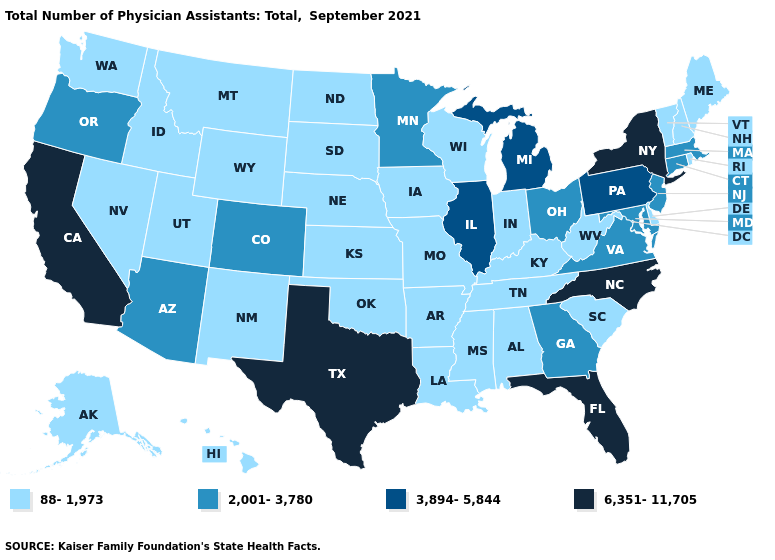Does Wisconsin have a higher value than Mississippi?
Write a very short answer. No. Does Missouri have the same value as Arizona?
Give a very brief answer. No. How many symbols are there in the legend?
Concise answer only. 4. How many symbols are there in the legend?
Answer briefly. 4. What is the lowest value in the Northeast?
Short answer required. 88-1,973. What is the value of Hawaii?
Write a very short answer. 88-1,973. Does the first symbol in the legend represent the smallest category?
Concise answer only. Yes. Does Maine have a higher value than Virginia?
Concise answer only. No. What is the value of Alabama?
Write a very short answer. 88-1,973. What is the value of Massachusetts?
Keep it brief. 2,001-3,780. Among the states that border New Jersey , which have the highest value?
Write a very short answer. New York. Does Maine have a lower value than Colorado?
Give a very brief answer. Yes. Does Michigan have the highest value in the MidWest?
Give a very brief answer. Yes. What is the value of New Hampshire?
Be succinct. 88-1,973. 